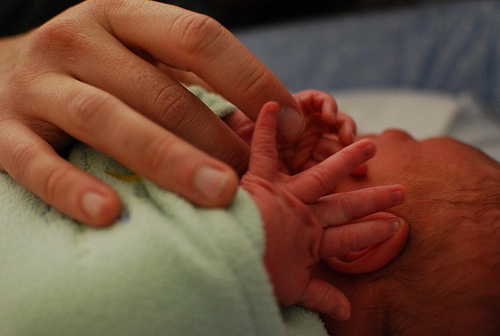<image>
Is the baby next to the cloth? Yes. The baby is positioned adjacent to the cloth, located nearby in the same general area. 